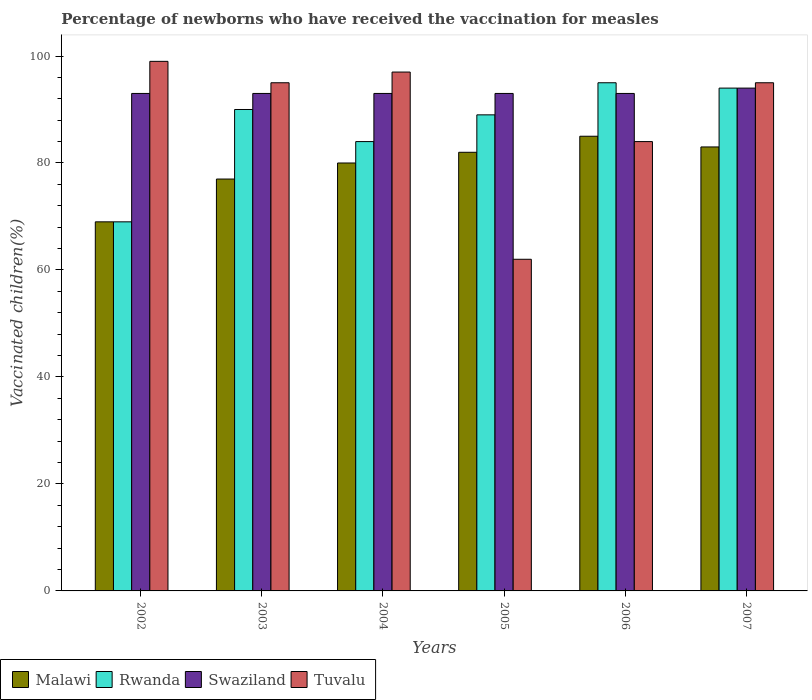How many different coloured bars are there?
Your answer should be compact. 4. How many groups of bars are there?
Provide a succinct answer. 6. Are the number of bars per tick equal to the number of legend labels?
Provide a succinct answer. Yes. Are the number of bars on each tick of the X-axis equal?
Provide a succinct answer. Yes. How many bars are there on the 1st tick from the left?
Provide a succinct answer. 4. What is the label of the 4th group of bars from the left?
Ensure brevity in your answer.  2005. In how many cases, is the number of bars for a given year not equal to the number of legend labels?
Offer a terse response. 0. What is the percentage of vaccinated children in Swaziland in 2002?
Provide a succinct answer. 93. Across all years, what is the maximum percentage of vaccinated children in Rwanda?
Offer a terse response. 95. Across all years, what is the minimum percentage of vaccinated children in Tuvalu?
Your answer should be very brief. 62. What is the total percentage of vaccinated children in Rwanda in the graph?
Your response must be concise. 521. What is the difference between the percentage of vaccinated children in Malawi in 2002 and that in 2005?
Give a very brief answer. -13. What is the difference between the percentage of vaccinated children in Swaziland in 2005 and the percentage of vaccinated children in Malawi in 2006?
Your answer should be compact. 8. What is the average percentage of vaccinated children in Rwanda per year?
Give a very brief answer. 86.83. In the year 2006, what is the difference between the percentage of vaccinated children in Rwanda and percentage of vaccinated children in Tuvalu?
Keep it short and to the point. 11. In how many years, is the percentage of vaccinated children in Tuvalu greater than 32 %?
Keep it short and to the point. 6. What is the ratio of the percentage of vaccinated children in Malawi in 2003 to that in 2007?
Ensure brevity in your answer.  0.93. Is the percentage of vaccinated children in Rwanda in 2002 less than that in 2005?
Give a very brief answer. Yes. What is the difference between the highest and the second highest percentage of vaccinated children in Swaziland?
Offer a very short reply. 1. What is the difference between the highest and the lowest percentage of vaccinated children in Tuvalu?
Ensure brevity in your answer.  37. Is the sum of the percentage of vaccinated children in Malawi in 2004 and 2005 greater than the maximum percentage of vaccinated children in Rwanda across all years?
Your answer should be very brief. Yes. Is it the case that in every year, the sum of the percentage of vaccinated children in Malawi and percentage of vaccinated children in Swaziland is greater than the sum of percentage of vaccinated children in Rwanda and percentage of vaccinated children in Tuvalu?
Keep it short and to the point. No. What does the 4th bar from the left in 2002 represents?
Ensure brevity in your answer.  Tuvalu. What does the 3rd bar from the right in 2004 represents?
Ensure brevity in your answer.  Rwanda. Is it the case that in every year, the sum of the percentage of vaccinated children in Swaziland and percentage of vaccinated children in Malawi is greater than the percentage of vaccinated children in Tuvalu?
Your answer should be very brief. Yes. Are all the bars in the graph horizontal?
Ensure brevity in your answer.  No. Are the values on the major ticks of Y-axis written in scientific E-notation?
Offer a very short reply. No. What is the title of the graph?
Your answer should be compact. Percentage of newborns who have received the vaccination for measles. Does "Malaysia" appear as one of the legend labels in the graph?
Ensure brevity in your answer.  No. What is the label or title of the X-axis?
Your answer should be very brief. Years. What is the label or title of the Y-axis?
Your answer should be very brief. Vaccinated children(%). What is the Vaccinated children(%) of Rwanda in 2002?
Offer a very short reply. 69. What is the Vaccinated children(%) in Swaziland in 2002?
Your response must be concise. 93. What is the Vaccinated children(%) of Malawi in 2003?
Offer a very short reply. 77. What is the Vaccinated children(%) in Swaziland in 2003?
Offer a very short reply. 93. What is the Vaccinated children(%) of Tuvalu in 2003?
Provide a short and direct response. 95. What is the Vaccinated children(%) of Swaziland in 2004?
Offer a terse response. 93. What is the Vaccinated children(%) in Tuvalu in 2004?
Provide a succinct answer. 97. What is the Vaccinated children(%) of Rwanda in 2005?
Provide a succinct answer. 89. What is the Vaccinated children(%) in Swaziland in 2005?
Keep it short and to the point. 93. What is the Vaccinated children(%) of Swaziland in 2006?
Make the answer very short. 93. What is the Vaccinated children(%) in Tuvalu in 2006?
Offer a very short reply. 84. What is the Vaccinated children(%) in Malawi in 2007?
Your answer should be compact. 83. What is the Vaccinated children(%) of Rwanda in 2007?
Your answer should be compact. 94. What is the Vaccinated children(%) in Swaziland in 2007?
Offer a terse response. 94. What is the Vaccinated children(%) in Tuvalu in 2007?
Provide a short and direct response. 95. Across all years, what is the maximum Vaccinated children(%) in Malawi?
Offer a very short reply. 85. Across all years, what is the maximum Vaccinated children(%) in Rwanda?
Offer a very short reply. 95. Across all years, what is the maximum Vaccinated children(%) in Swaziland?
Provide a short and direct response. 94. Across all years, what is the maximum Vaccinated children(%) of Tuvalu?
Keep it short and to the point. 99. Across all years, what is the minimum Vaccinated children(%) of Malawi?
Provide a succinct answer. 69. Across all years, what is the minimum Vaccinated children(%) in Swaziland?
Provide a short and direct response. 93. Across all years, what is the minimum Vaccinated children(%) of Tuvalu?
Make the answer very short. 62. What is the total Vaccinated children(%) of Malawi in the graph?
Your response must be concise. 476. What is the total Vaccinated children(%) of Rwanda in the graph?
Provide a succinct answer. 521. What is the total Vaccinated children(%) in Swaziland in the graph?
Ensure brevity in your answer.  559. What is the total Vaccinated children(%) in Tuvalu in the graph?
Provide a succinct answer. 532. What is the difference between the Vaccinated children(%) in Malawi in 2002 and that in 2003?
Offer a very short reply. -8. What is the difference between the Vaccinated children(%) of Rwanda in 2002 and that in 2003?
Keep it short and to the point. -21. What is the difference between the Vaccinated children(%) of Tuvalu in 2002 and that in 2003?
Offer a terse response. 4. What is the difference between the Vaccinated children(%) in Malawi in 2002 and that in 2004?
Your answer should be compact. -11. What is the difference between the Vaccinated children(%) in Rwanda in 2002 and that in 2004?
Make the answer very short. -15. What is the difference between the Vaccinated children(%) of Tuvalu in 2002 and that in 2004?
Make the answer very short. 2. What is the difference between the Vaccinated children(%) of Rwanda in 2002 and that in 2005?
Provide a succinct answer. -20. What is the difference between the Vaccinated children(%) of Tuvalu in 2002 and that in 2005?
Provide a short and direct response. 37. What is the difference between the Vaccinated children(%) of Swaziland in 2002 and that in 2006?
Provide a short and direct response. 0. What is the difference between the Vaccinated children(%) of Malawi in 2002 and that in 2007?
Keep it short and to the point. -14. What is the difference between the Vaccinated children(%) of Rwanda in 2002 and that in 2007?
Give a very brief answer. -25. What is the difference between the Vaccinated children(%) of Rwanda in 2003 and that in 2004?
Your response must be concise. 6. What is the difference between the Vaccinated children(%) in Rwanda in 2003 and that in 2005?
Give a very brief answer. 1. What is the difference between the Vaccinated children(%) of Swaziland in 2003 and that in 2005?
Keep it short and to the point. 0. What is the difference between the Vaccinated children(%) of Rwanda in 2003 and that in 2006?
Provide a succinct answer. -5. What is the difference between the Vaccinated children(%) of Tuvalu in 2003 and that in 2006?
Make the answer very short. 11. What is the difference between the Vaccinated children(%) of Malawi in 2003 and that in 2007?
Your answer should be very brief. -6. What is the difference between the Vaccinated children(%) of Swaziland in 2003 and that in 2007?
Your answer should be very brief. -1. What is the difference between the Vaccinated children(%) of Tuvalu in 2004 and that in 2005?
Your response must be concise. 35. What is the difference between the Vaccinated children(%) of Malawi in 2004 and that in 2006?
Make the answer very short. -5. What is the difference between the Vaccinated children(%) in Malawi in 2005 and that in 2006?
Keep it short and to the point. -3. What is the difference between the Vaccinated children(%) in Tuvalu in 2005 and that in 2006?
Provide a short and direct response. -22. What is the difference between the Vaccinated children(%) in Tuvalu in 2005 and that in 2007?
Your answer should be very brief. -33. What is the difference between the Vaccinated children(%) in Rwanda in 2006 and that in 2007?
Give a very brief answer. 1. What is the difference between the Vaccinated children(%) in Swaziland in 2006 and that in 2007?
Offer a terse response. -1. What is the difference between the Vaccinated children(%) of Tuvalu in 2006 and that in 2007?
Offer a very short reply. -11. What is the difference between the Vaccinated children(%) in Rwanda in 2002 and the Vaccinated children(%) in Swaziland in 2003?
Keep it short and to the point. -24. What is the difference between the Vaccinated children(%) in Malawi in 2002 and the Vaccinated children(%) in Rwanda in 2004?
Your response must be concise. -15. What is the difference between the Vaccinated children(%) of Rwanda in 2002 and the Vaccinated children(%) of Tuvalu in 2004?
Your answer should be very brief. -28. What is the difference between the Vaccinated children(%) of Swaziland in 2002 and the Vaccinated children(%) of Tuvalu in 2004?
Ensure brevity in your answer.  -4. What is the difference between the Vaccinated children(%) in Malawi in 2002 and the Vaccinated children(%) in Swaziland in 2005?
Your response must be concise. -24. What is the difference between the Vaccinated children(%) in Rwanda in 2002 and the Vaccinated children(%) in Swaziland in 2005?
Offer a terse response. -24. What is the difference between the Vaccinated children(%) in Swaziland in 2002 and the Vaccinated children(%) in Tuvalu in 2005?
Keep it short and to the point. 31. What is the difference between the Vaccinated children(%) in Malawi in 2002 and the Vaccinated children(%) in Rwanda in 2006?
Ensure brevity in your answer.  -26. What is the difference between the Vaccinated children(%) in Malawi in 2002 and the Vaccinated children(%) in Swaziland in 2006?
Keep it short and to the point. -24. What is the difference between the Vaccinated children(%) of Rwanda in 2002 and the Vaccinated children(%) of Swaziland in 2006?
Give a very brief answer. -24. What is the difference between the Vaccinated children(%) in Rwanda in 2002 and the Vaccinated children(%) in Tuvalu in 2006?
Keep it short and to the point. -15. What is the difference between the Vaccinated children(%) of Rwanda in 2002 and the Vaccinated children(%) of Swaziland in 2007?
Provide a short and direct response. -25. What is the difference between the Vaccinated children(%) in Swaziland in 2002 and the Vaccinated children(%) in Tuvalu in 2007?
Give a very brief answer. -2. What is the difference between the Vaccinated children(%) of Malawi in 2003 and the Vaccinated children(%) of Rwanda in 2004?
Your answer should be compact. -7. What is the difference between the Vaccinated children(%) of Malawi in 2003 and the Vaccinated children(%) of Swaziland in 2004?
Keep it short and to the point. -16. What is the difference between the Vaccinated children(%) in Malawi in 2003 and the Vaccinated children(%) in Tuvalu in 2004?
Make the answer very short. -20. What is the difference between the Vaccinated children(%) of Rwanda in 2003 and the Vaccinated children(%) of Swaziland in 2004?
Ensure brevity in your answer.  -3. What is the difference between the Vaccinated children(%) in Rwanda in 2003 and the Vaccinated children(%) in Tuvalu in 2004?
Make the answer very short. -7. What is the difference between the Vaccinated children(%) in Malawi in 2003 and the Vaccinated children(%) in Swaziland in 2005?
Offer a very short reply. -16. What is the difference between the Vaccinated children(%) of Malawi in 2003 and the Vaccinated children(%) of Tuvalu in 2005?
Provide a short and direct response. 15. What is the difference between the Vaccinated children(%) in Swaziland in 2003 and the Vaccinated children(%) in Tuvalu in 2005?
Keep it short and to the point. 31. What is the difference between the Vaccinated children(%) of Malawi in 2003 and the Vaccinated children(%) of Swaziland in 2006?
Make the answer very short. -16. What is the difference between the Vaccinated children(%) in Malawi in 2003 and the Vaccinated children(%) in Tuvalu in 2006?
Your answer should be compact. -7. What is the difference between the Vaccinated children(%) of Rwanda in 2003 and the Vaccinated children(%) of Tuvalu in 2006?
Offer a terse response. 6. What is the difference between the Vaccinated children(%) of Malawi in 2003 and the Vaccinated children(%) of Swaziland in 2007?
Offer a terse response. -17. What is the difference between the Vaccinated children(%) of Rwanda in 2003 and the Vaccinated children(%) of Tuvalu in 2007?
Provide a short and direct response. -5. What is the difference between the Vaccinated children(%) of Malawi in 2004 and the Vaccinated children(%) of Rwanda in 2005?
Keep it short and to the point. -9. What is the difference between the Vaccinated children(%) in Malawi in 2004 and the Vaccinated children(%) in Tuvalu in 2005?
Offer a very short reply. 18. What is the difference between the Vaccinated children(%) in Malawi in 2004 and the Vaccinated children(%) in Rwanda in 2006?
Keep it short and to the point. -15. What is the difference between the Vaccinated children(%) in Malawi in 2004 and the Vaccinated children(%) in Tuvalu in 2006?
Offer a very short reply. -4. What is the difference between the Vaccinated children(%) of Malawi in 2004 and the Vaccinated children(%) of Tuvalu in 2007?
Your answer should be very brief. -15. What is the difference between the Vaccinated children(%) of Rwanda in 2004 and the Vaccinated children(%) of Swaziland in 2007?
Provide a succinct answer. -10. What is the difference between the Vaccinated children(%) of Rwanda in 2004 and the Vaccinated children(%) of Tuvalu in 2007?
Provide a succinct answer. -11. What is the difference between the Vaccinated children(%) in Malawi in 2005 and the Vaccinated children(%) in Swaziland in 2006?
Make the answer very short. -11. What is the difference between the Vaccinated children(%) of Malawi in 2005 and the Vaccinated children(%) of Tuvalu in 2006?
Keep it short and to the point. -2. What is the difference between the Vaccinated children(%) of Rwanda in 2005 and the Vaccinated children(%) of Tuvalu in 2006?
Offer a terse response. 5. What is the difference between the Vaccinated children(%) of Malawi in 2005 and the Vaccinated children(%) of Tuvalu in 2007?
Provide a succinct answer. -13. What is the difference between the Vaccinated children(%) of Rwanda in 2005 and the Vaccinated children(%) of Swaziland in 2007?
Your answer should be very brief. -5. What is the difference between the Vaccinated children(%) of Malawi in 2006 and the Vaccinated children(%) of Rwanda in 2007?
Ensure brevity in your answer.  -9. What is the difference between the Vaccinated children(%) of Malawi in 2006 and the Vaccinated children(%) of Swaziland in 2007?
Your response must be concise. -9. What is the difference between the Vaccinated children(%) in Malawi in 2006 and the Vaccinated children(%) in Tuvalu in 2007?
Give a very brief answer. -10. What is the difference between the Vaccinated children(%) in Rwanda in 2006 and the Vaccinated children(%) in Swaziland in 2007?
Provide a short and direct response. 1. What is the difference between the Vaccinated children(%) in Rwanda in 2006 and the Vaccinated children(%) in Tuvalu in 2007?
Provide a short and direct response. 0. What is the difference between the Vaccinated children(%) of Swaziland in 2006 and the Vaccinated children(%) of Tuvalu in 2007?
Offer a very short reply. -2. What is the average Vaccinated children(%) in Malawi per year?
Offer a very short reply. 79.33. What is the average Vaccinated children(%) of Rwanda per year?
Provide a short and direct response. 86.83. What is the average Vaccinated children(%) in Swaziland per year?
Offer a terse response. 93.17. What is the average Vaccinated children(%) in Tuvalu per year?
Keep it short and to the point. 88.67. In the year 2002, what is the difference between the Vaccinated children(%) of Malawi and Vaccinated children(%) of Rwanda?
Give a very brief answer. 0. In the year 2002, what is the difference between the Vaccinated children(%) in Rwanda and Vaccinated children(%) in Swaziland?
Your answer should be compact. -24. In the year 2002, what is the difference between the Vaccinated children(%) of Rwanda and Vaccinated children(%) of Tuvalu?
Give a very brief answer. -30. In the year 2003, what is the difference between the Vaccinated children(%) of Rwanda and Vaccinated children(%) of Swaziland?
Offer a very short reply. -3. In the year 2005, what is the difference between the Vaccinated children(%) of Malawi and Vaccinated children(%) of Tuvalu?
Make the answer very short. 20. In the year 2005, what is the difference between the Vaccinated children(%) of Rwanda and Vaccinated children(%) of Tuvalu?
Provide a short and direct response. 27. In the year 2006, what is the difference between the Vaccinated children(%) of Malawi and Vaccinated children(%) of Rwanda?
Ensure brevity in your answer.  -10. In the year 2006, what is the difference between the Vaccinated children(%) in Malawi and Vaccinated children(%) in Swaziland?
Your answer should be compact. -8. In the year 2006, what is the difference between the Vaccinated children(%) of Malawi and Vaccinated children(%) of Tuvalu?
Your response must be concise. 1. In the year 2006, what is the difference between the Vaccinated children(%) of Rwanda and Vaccinated children(%) of Swaziland?
Provide a succinct answer. 2. In the year 2007, what is the difference between the Vaccinated children(%) in Rwanda and Vaccinated children(%) in Swaziland?
Make the answer very short. 0. In the year 2007, what is the difference between the Vaccinated children(%) of Swaziland and Vaccinated children(%) of Tuvalu?
Give a very brief answer. -1. What is the ratio of the Vaccinated children(%) in Malawi in 2002 to that in 2003?
Your response must be concise. 0.9. What is the ratio of the Vaccinated children(%) of Rwanda in 2002 to that in 2003?
Your response must be concise. 0.77. What is the ratio of the Vaccinated children(%) of Swaziland in 2002 to that in 2003?
Offer a terse response. 1. What is the ratio of the Vaccinated children(%) of Tuvalu in 2002 to that in 2003?
Offer a terse response. 1.04. What is the ratio of the Vaccinated children(%) of Malawi in 2002 to that in 2004?
Offer a very short reply. 0.86. What is the ratio of the Vaccinated children(%) of Rwanda in 2002 to that in 2004?
Give a very brief answer. 0.82. What is the ratio of the Vaccinated children(%) of Swaziland in 2002 to that in 2004?
Your response must be concise. 1. What is the ratio of the Vaccinated children(%) in Tuvalu in 2002 to that in 2004?
Your answer should be compact. 1.02. What is the ratio of the Vaccinated children(%) in Malawi in 2002 to that in 2005?
Your answer should be compact. 0.84. What is the ratio of the Vaccinated children(%) in Rwanda in 2002 to that in 2005?
Provide a short and direct response. 0.78. What is the ratio of the Vaccinated children(%) of Swaziland in 2002 to that in 2005?
Give a very brief answer. 1. What is the ratio of the Vaccinated children(%) in Tuvalu in 2002 to that in 2005?
Your answer should be compact. 1.6. What is the ratio of the Vaccinated children(%) in Malawi in 2002 to that in 2006?
Offer a very short reply. 0.81. What is the ratio of the Vaccinated children(%) in Rwanda in 2002 to that in 2006?
Your response must be concise. 0.73. What is the ratio of the Vaccinated children(%) of Swaziland in 2002 to that in 2006?
Your response must be concise. 1. What is the ratio of the Vaccinated children(%) in Tuvalu in 2002 to that in 2006?
Your answer should be very brief. 1.18. What is the ratio of the Vaccinated children(%) in Malawi in 2002 to that in 2007?
Give a very brief answer. 0.83. What is the ratio of the Vaccinated children(%) in Rwanda in 2002 to that in 2007?
Provide a short and direct response. 0.73. What is the ratio of the Vaccinated children(%) of Tuvalu in 2002 to that in 2007?
Your response must be concise. 1.04. What is the ratio of the Vaccinated children(%) of Malawi in 2003 to that in 2004?
Ensure brevity in your answer.  0.96. What is the ratio of the Vaccinated children(%) of Rwanda in 2003 to that in 2004?
Your answer should be compact. 1.07. What is the ratio of the Vaccinated children(%) in Swaziland in 2003 to that in 2004?
Give a very brief answer. 1. What is the ratio of the Vaccinated children(%) in Tuvalu in 2003 to that in 2004?
Offer a very short reply. 0.98. What is the ratio of the Vaccinated children(%) of Malawi in 2003 to that in 2005?
Your answer should be compact. 0.94. What is the ratio of the Vaccinated children(%) of Rwanda in 2003 to that in 2005?
Make the answer very short. 1.01. What is the ratio of the Vaccinated children(%) in Tuvalu in 2003 to that in 2005?
Keep it short and to the point. 1.53. What is the ratio of the Vaccinated children(%) in Malawi in 2003 to that in 2006?
Offer a terse response. 0.91. What is the ratio of the Vaccinated children(%) in Rwanda in 2003 to that in 2006?
Provide a short and direct response. 0.95. What is the ratio of the Vaccinated children(%) in Tuvalu in 2003 to that in 2006?
Give a very brief answer. 1.13. What is the ratio of the Vaccinated children(%) of Malawi in 2003 to that in 2007?
Offer a very short reply. 0.93. What is the ratio of the Vaccinated children(%) in Rwanda in 2003 to that in 2007?
Offer a terse response. 0.96. What is the ratio of the Vaccinated children(%) of Malawi in 2004 to that in 2005?
Your response must be concise. 0.98. What is the ratio of the Vaccinated children(%) of Rwanda in 2004 to that in 2005?
Your answer should be compact. 0.94. What is the ratio of the Vaccinated children(%) of Swaziland in 2004 to that in 2005?
Give a very brief answer. 1. What is the ratio of the Vaccinated children(%) in Tuvalu in 2004 to that in 2005?
Offer a terse response. 1.56. What is the ratio of the Vaccinated children(%) of Rwanda in 2004 to that in 2006?
Keep it short and to the point. 0.88. What is the ratio of the Vaccinated children(%) of Swaziland in 2004 to that in 2006?
Your answer should be very brief. 1. What is the ratio of the Vaccinated children(%) in Tuvalu in 2004 to that in 2006?
Provide a succinct answer. 1.15. What is the ratio of the Vaccinated children(%) of Malawi in 2004 to that in 2007?
Provide a succinct answer. 0.96. What is the ratio of the Vaccinated children(%) of Rwanda in 2004 to that in 2007?
Provide a succinct answer. 0.89. What is the ratio of the Vaccinated children(%) in Swaziland in 2004 to that in 2007?
Offer a terse response. 0.99. What is the ratio of the Vaccinated children(%) of Tuvalu in 2004 to that in 2007?
Offer a very short reply. 1.02. What is the ratio of the Vaccinated children(%) of Malawi in 2005 to that in 2006?
Offer a terse response. 0.96. What is the ratio of the Vaccinated children(%) in Rwanda in 2005 to that in 2006?
Ensure brevity in your answer.  0.94. What is the ratio of the Vaccinated children(%) in Tuvalu in 2005 to that in 2006?
Make the answer very short. 0.74. What is the ratio of the Vaccinated children(%) in Rwanda in 2005 to that in 2007?
Ensure brevity in your answer.  0.95. What is the ratio of the Vaccinated children(%) of Tuvalu in 2005 to that in 2007?
Your answer should be very brief. 0.65. What is the ratio of the Vaccinated children(%) of Malawi in 2006 to that in 2007?
Your response must be concise. 1.02. What is the ratio of the Vaccinated children(%) in Rwanda in 2006 to that in 2007?
Your response must be concise. 1.01. What is the ratio of the Vaccinated children(%) of Tuvalu in 2006 to that in 2007?
Make the answer very short. 0.88. What is the difference between the highest and the second highest Vaccinated children(%) of Malawi?
Provide a short and direct response. 2. What is the difference between the highest and the second highest Vaccinated children(%) in Tuvalu?
Make the answer very short. 2. What is the difference between the highest and the lowest Vaccinated children(%) of Malawi?
Your answer should be very brief. 16. What is the difference between the highest and the lowest Vaccinated children(%) in Swaziland?
Make the answer very short. 1. 